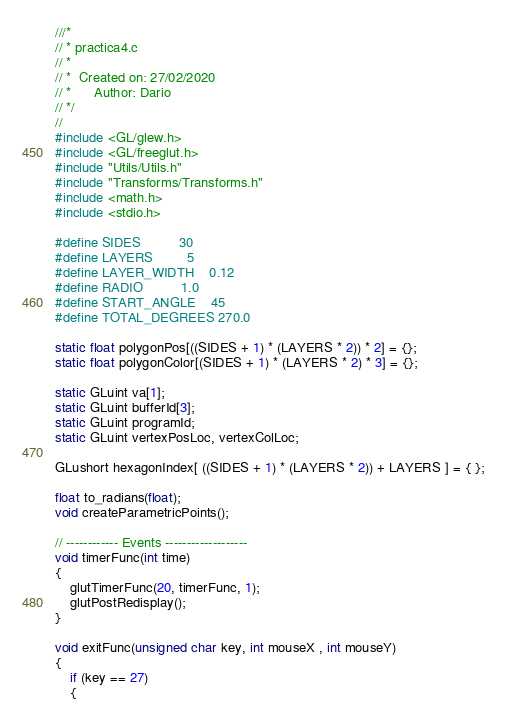Convert code to text. <code><loc_0><loc_0><loc_500><loc_500><_C_>///*
// * practica4.c
// *
// *  Created on: 27/02/2020
// *      Author: Dario
// */
//
#include <GL/glew.h>
#include <GL/freeglut.h>
#include "Utils/Utils.h"
#include "Transforms/Transforms.h"
#include <math.h>
#include <stdio.h>

#define SIDES          30
#define LAYERS         5
#define LAYER_WIDTH    0.12
#define RADIO          1.0
#define START_ANGLE    45
#define TOTAL_DEGREES 270.0

static float polygonPos[((SIDES + 1) * (LAYERS * 2)) * 2] = {};
static float polygonColor[(SIDES + 1) * (LAYERS * 2) * 3] = {};

static GLuint va[1];
static GLuint bufferId[3];
static GLuint programId;
static GLuint vertexPosLoc, vertexColLoc;

GLushort hexagonIndex[ ((SIDES + 1) * (LAYERS * 2)) + LAYERS ] = { };

float to_radians(float);
void createParametricPoints();

// ------------ Events -------------------
void timerFunc(int time)
{
	glutTimerFunc(20, timerFunc, 1);
	glutPostRedisplay();
}

void exitFunc(unsigned char key, int mouseX , int mouseY)
{
	if (key == 27)
	{</code> 